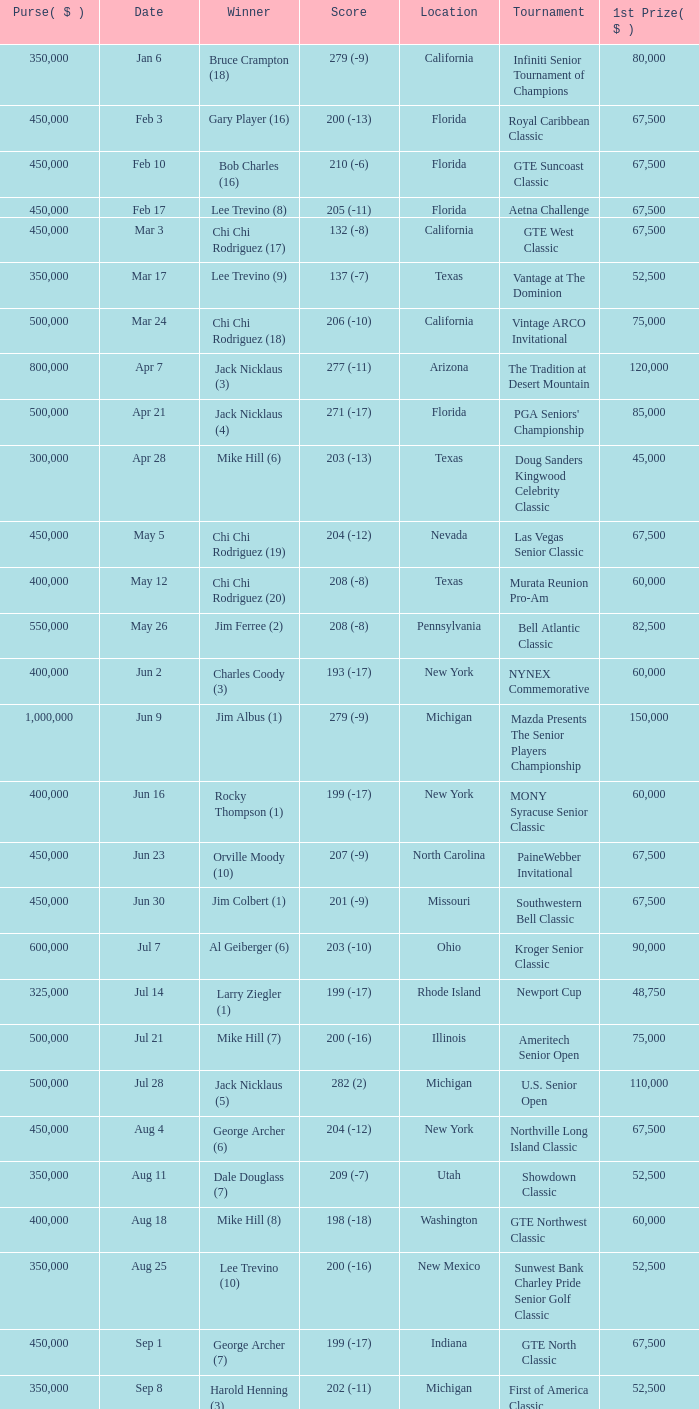Where was the security pacific senior classic? California. 